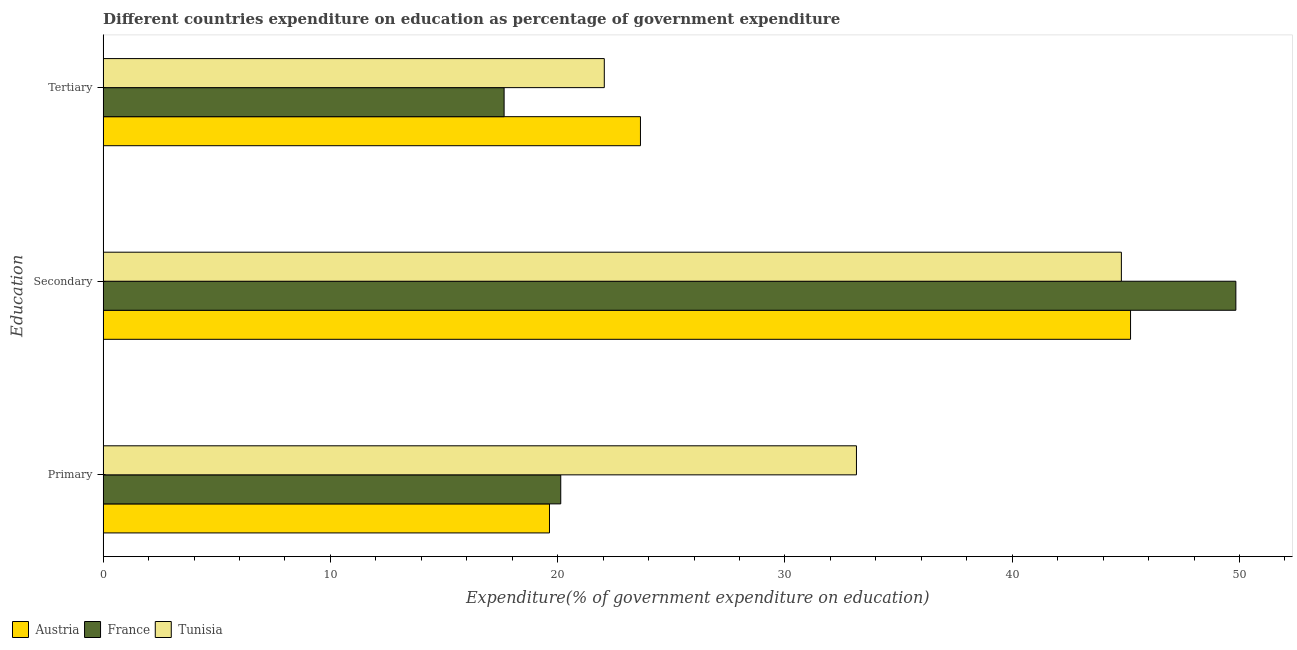How many bars are there on the 3rd tick from the top?
Offer a very short reply. 3. What is the label of the 2nd group of bars from the top?
Provide a short and direct response. Secondary. What is the expenditure on primary education in Austria?
Keep it short and to the point. 19.64. Across all countries, what is the maximum expenditure on secondary education?
Offer a terse response. 49.84. Across all countries, what is the minimum expenditure on primary education?
Your response must be concise. 19.64. In which country was the expenditure on primary education maximum?
Your answer should be very brief. Tunisia. What is the total expenditure on primary education in the graph?
Your answer should be very brief. 72.92. What is the difference between the expenditure on tertiary education in Tunisia and that in Austria?
Provide a succinct answer. -1.59. What is the difference between the expenditure on primary education in France and the expenditure on secondary education in Austria?
Your answer should be very brief. -25.07. What is the average expenditure on secondary education per country?
Your response must be concise. 46.62. What is the difference between the expenditure on primary education and expenditure on secondary education in Tunisia?
Make the answer very short. -11.66. In how many countries, is the expenditure on primary education greater than 28 %?
Your answer should be compact. 1. What is the ratio of the expenditure on primary education in Austria to that in France?
Provide a short and direct response. 0.98. Is the expenditure on secondary education in Tunisia less than that in France?
Your answer should be very brief. Yes. Is the difference between the expenditure on secondary education in Austria and Tunisia greater than the difference between the expenditure on tertiary education in Austria and Tunisia?
Your response must be concise. No. What is the difference between the highest and the second highest expenditure on tertiary education?
Your answer should be very brief. 1.59. What is the difference between the highest and the lowest expenditure on primary education?
Give a very brief answer. 13.51. In how many countries, is the expenditure on secondary education greater than the average expenditure on secondary education taken over all countries?
Give a very brief answer. 1. What does the 2nd bar from the top in Primary represents?
Ensure brevity in your answer.  France. What does the 3rd bar from the bottom in Secondary represents?
Provide a short and direct response. Tunisia. Is it the case that in every country, the sum of the expenditure on primary education and expenditure on secondary education is greater than the expenditure on tertiary education?
Make the answer very short. Yes. Are all the bars in the graph horizontal?
Offer a terse response. Yes. How many countries are there in the graph?
Provide a succinct answer. 3. What is the difference between two consecutive major ticks on the X-axis?
Your answer should be compact. 10. Are the values on the major ticks of X-axis written in scientific E-notation?
Keep it short and to the point. No. Does the graph contain grids?
Your answer should be very brief. No. What is the title of the graph?
Your answer should be compact. Different countries expenditure on education as percentage of government expenditure. What is the label or title of the X-axis?
Your response must be concise. Expenditure(% of government expenditure on education). What is the label or title of the Y-axis?
Provide a succinct answer. Education. What is the Expenditure(% of government expenditure on education) in Austria in Primary?
Your response must be concise. 19.64. What is the Expenditure(% of government expenditure on education) of France in Primary?
Your response must be concise. 20.13. What is the Expenditure(% of government expenditure on education) in Tunisia in Primary?
Give a very brief answer. 33.15. What is the Expenditure(% of government expenditure on education) in Austria in Secondary?
Provide a short and direct response. 45.21. What is the Expenditure(% of government expenditure on education) in France in Secondary?
Your response must be concise. 49.84. What is the Expenditure(% of government expenditure on education) of Tunisia in Secondary?
Ensure brevity in your answer.  44.8. What is the Expenditure(% of government expenditure on education) in Austria in Tertiary?
Make the answer very short. 23.64. What is the Expenditure(% of government expenditure on education) of France in Tertiary?
Your answer should be very brief. 17.64. What is the Expenditure(% of government expenditure on education) of Tunisia in Tertiary?
Ensure brevity in your answer.  22.05. Across all Education, what is the maximum Expenditure(% of government expenditure on education) in Austria?
Provide a short and direct response. 45.21. Across all Education, what is the maximum Expenditure(% of government expenditure on education) of France?
Your answer should be compact. 49.84. Across all Education, what is the maximum Expenditure(% of government expenditure on education) of Tunisia?
Offer a terse response. 44.8. Across all Education, what is the minimum Expenditure(% of government expenditure on education) in Austria?
Offer a terse response. 19.64. Across all Education, what is the minimum Expenditure(% of government expenditure on education) in France?
Offer a terse response. 17.64. Across all Education, what is the minimum Expenditure(% of government expenditure on education) of Tunisia?
Ensure brevity in your answer.  22.05. What is the total Expenditure(% of government expenditure on education) of Austria in the graph?
Offer a very short reply. 88.49. What is the total Expenditure(% of government expenditure on education) in France in the graph?
Give a very brief answer. 87.62. What is the difference between the Expenditure(% of government expenditure on education) of Austria in Primary and that in Secondary?
Offer a terse response. -25.57. What is the difference between the Expenditure(% of government expenditure on education) in France in Primary and that in Secondary?
Your answer should be very brief. -29.71. What is the difference between the Expenditure(% of government expenditure on education) of Tunisia in Primary and that in Secondary?
Provide a succinct answer. -11.66. What is the difference between the Expenditure(% of government expenditure on education) in Austria in Primary and that in Tertiary?
Provide a short and direct response. -4. What is the difference between the Expenditure(% of government expenditure on education) of France in Primary and that in Tertiary?
Your response must be concise. 2.49. What is the difference between the Expenditure(% of government expenditure on education) of Tunisia in Primary and that in Tertiary?
Your response must be concise. 11.09. What is the difference between the Expenditure(% of government expenditure on education) of Austria in Secondary and that in Tertiary?
Your answer should be compact. 21.56. What is the difference between the Expenditure(% of government expenditure on education) of France in Secondary and that in Tertiary?
Your response must be concise. 32.2. What is the difference between the Expenditure(% of government expenditure on education) in Tunisia in Secondary and that in Tertiary?
Keep it short and to the point. 22.75. What is the difference between the Expenditure(% of government expenditure on education) in Austria in Primary and the Expenditure(% of government expenditure on education) in France in Secondary?
Offer a terse response. -30.2. What is the difference between the Expenditure(% of government expenditure on education) of Austria in Primary and the Expenditure(% of government expenditure on education) of Tunisia in Secondary?
Keep it short and to the point. -25.16. What is the difference between the Expenditure(% of government expenditure on education) in France in Primary and the Expenditure(% of government expenditure on education) in Tunisia in Secondary?
Offer a very short reply. -24.67. What is the difference between the Expenditure(% of government expenditure on education) in Austria in Primary and the Expenditure(% of government expenditure on education) in France in Tertiary?
Ensure brevity in your answer.  2. What is the difference between the Expenditure(% of government expenditure on education) in Austria in Primary and the Expenditure(% of government expenditure on education) in Tunisia in Tertiary?
Offer a terse response. -2.41. What is the difference between the Expenditure(% of government expenditure on education) in France in Primary and the Expenditure(% of government expenditure on education) in Tunisia in Tertiary?
Your response must be concise. -1.92. What is the difference between the Expenditure(% of government expenditure on education) in Austria in Secondary and the Expenditure(% of government expenditure on education) in France in Tertiary?
Provide a succinct answer. 27.56. What is the difference between the Expenditure(% of government expenditure on education) of Austria in Secondary and the Expenditure(% of government expenditure on education) of Tunisia in Tertiary?
Provide a succinct answer. 23.16. What is the difference between the Expenditure(% of government expenditure on education) in France in Secondary and the Expenditure(% of government expenditure on education) in Tunisia in Tertiary?
Make the answer very short. 27.79. What is the average Expenditure(% of government expenditure on education) in Austria per Education?
Offer a very short reply. 29.5. What is the average Expenditure(% of government expenditure on education) of France per Education?
Make the answer very short. 29.21. What is the average Expenditure(% of government expenditure on education) of Tunisia per Education?
Your answer should be compact. 33.33. What is the difference between the Expenditure(% of government expenditure on education) in Austria and Expenditure(% of government expenditure on education) in France in Primary?
Provide a short and direct response. -0.5. What is the difference between the Expenditure(% of government expenditure on education) in Austria and Expenditure(% of government expenditure on education) in Tunisia in Primary?
Keep it short and to the point. -13.51. What is the difference between the Expenditure(% of government expenditure on education) of France and Expenditure(% of government expenditure on education) of Tunisia in Primary?
Offer a very short reply. -13.01. What is the difference between the Expenditure(% of government expenditure on education) in Austria and Expenditure(% of government expenditure on education) in France in Secondary?
Offer a very short reply. -4.63. What is the difference between the Expenditure(% of government expenditure on education) of Austria and Expenditure(% of government expenditure on education) of Tunisia in Secondary?
Your answer should be very brief. 0.4. What is the difference between the Expenditure(% of government expenditure on education) in France and Expenditure(% of government expenditure on education) in Tunisia in Secondary?
Offer a terse response. 5.04. What is the difference between the Expenditure(% of government expenditure on education) in Austria and Expenditure(% of government expenditure on education) in France in Tertiary?
Keep it short and to the point. 6. What is the difference between the Expenditure(% of government expenditure on education) in Austria and Expenditure(% of government expenditure on education) in Tunisia in Tertiary?
Your answer should be compact. 1.59. What is the difference between the Expenditure(% of government expenditure on education) in France and Expenditure(% of government expenditure on education) in Tunisia in Tertiary?
Make the answer very short. -4.41. What is the ratio of the Expenditure(% of government expenditure on education) in Austria in Primary to that in Secondary?
Ensure brevity in your answer.  0.43. What is the ratio of the Expenditure(% of government expenditure on education) of France in Primary to that in Secondary?
Make the answer very short. 0.4. What is the ratio of the Expenditure(% of government expenditure on education) of Tunisia in Primary to that in Secondary?
Keep it short and to the point. 0.74. What is the ratio of the Expenditure(% of government expenditure on education) of Austria in Primary to that in Tertiary?
Make the answer very short. 0.83. What is the ratio of the Expenditure(% of government expenditure on education) in France in Primary to that in Tertiary?
Offer a very short reply. 1.14. What is the ratio of the Expenditure(% of government expenditure on education) in Tunisia in Primary to that in Tertiary?
Provide a succinct answer. 1.5. What is the ratio of the Expenditure(% of government expenditure on education) of Austria in Secondary to that in Tertiary?
Offer a very short reply. 1.91. What is the ratio of the Expenditure(% of government expenditure on education) in France in Secondary to that in Tertiary?
Ensure brevity in your answer.  2.82. What is the ratio of the Expenditure(% of government expenditure on education) of Tunisia in Secondary to that in Tertiary?
Offer a terse response. 2.03. What is the difference between the highest and the second highest Expenditure(% of government expenditure on education) of Austria?
Provide a succinct answer. 21.56. What is the difference between the highest and the second highest Expenditure(% of government expenditure on education) in France?
Ensure brevity in your answer.  29.71. What is the difference between the highest and the second highest Expenditure(% of government expenditure on education) of Tunisia?
Offer a very short reply. 11.66. What is the difference between the highest and the lowest Expenditure(% of government expenditure on education) in Austria?
Provide a succinct answer. 25.57. What is the difference between the highest and the lowest Expenditure(% of government expenditure on education) in France?
Provide a succinct answer. 32.2. What is the difference between the highest and the lowest Expenditure(% of government expenditure on education) of Tunisia?
Keep it short and to the point. 22.75. 